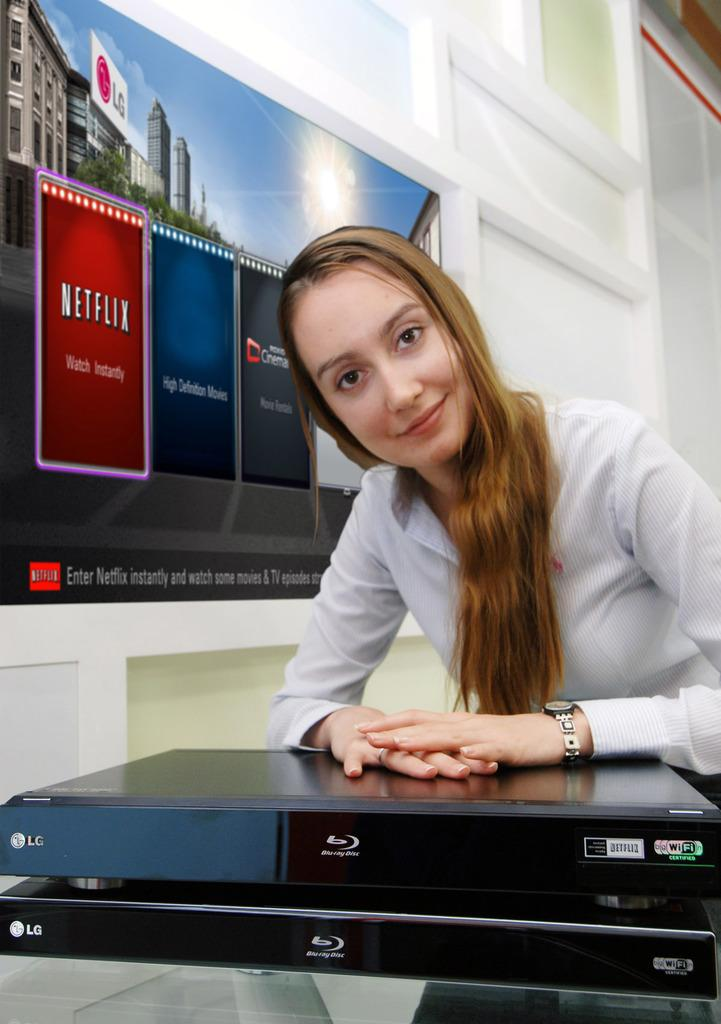<image>
Offer a succinct explanation of the picture presented. a lady that is next to a Netflix sign on her right 